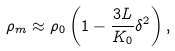Convert formula to latex. <formula><loc_0><loc_0><loc_500><loc_500>\rho _ { m } \approx \rho _ { 0 } \left ( 1 - \frac { 3 L } { K _ { 0 } } \delta ^ { 2 } \right ) ,</formula> 